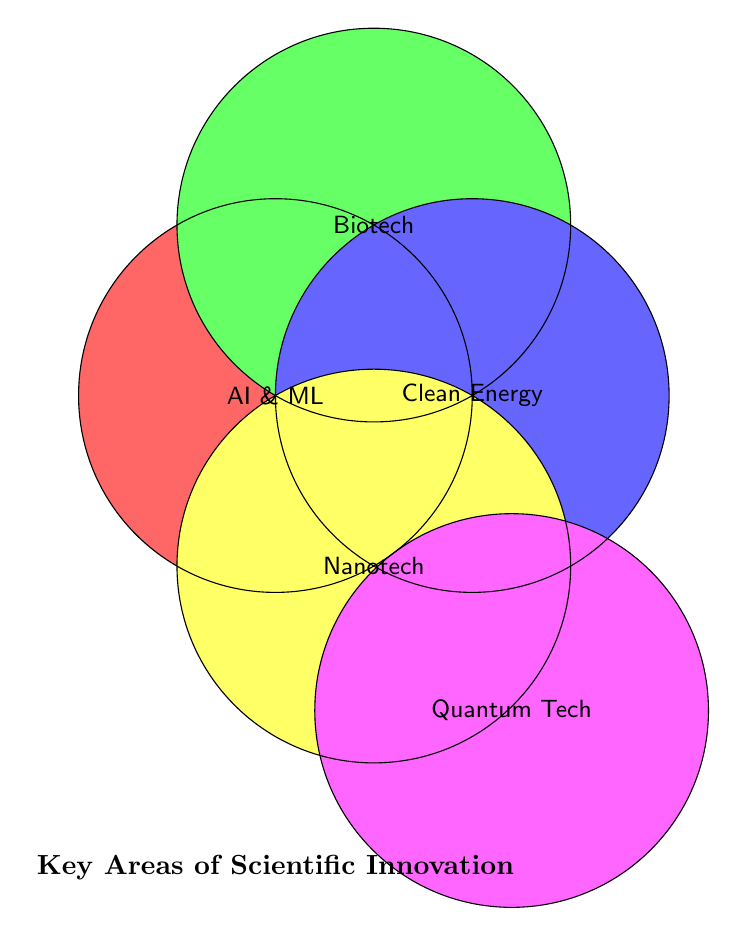What's the title of the diagram? The title is given at the bottom of the Venn Diagram, which indicates the main topic or focus of the visual information.
Answer: Key Areas of Scientific Innovation How many categories are included in the diagram? By looking at the labeled circles, there are five distinct categories.
Answer: Five Which category is represented by a pink circle? The pink circle is labeled "Quantum Tech".
Answer: Quantum Tech Do AI & ML and Biotech overlap in this Venn Diagram? By examining the position of the circles, it is clear that AI & ML and Biotech do not intersect.
Answer: No Which categories intersect in the Venn Diagram? Each circle is colored separately without any overlapping areas, indicating that none of the categories intersect in this Venn Diagram.
Answer: None What color represents the Nanotech category? The Nanotech category is represented by a yellow circle.
Answer: Yellow Are Quantum Tech and Clean Energy overlapping in the Venn Diagram? By checking the positions of the respective circles, they do not overlap.
Answer: No Which category is represented by a blue circle? The blue circle is labeled "Clean Energy".
Answer: Clean Energy 